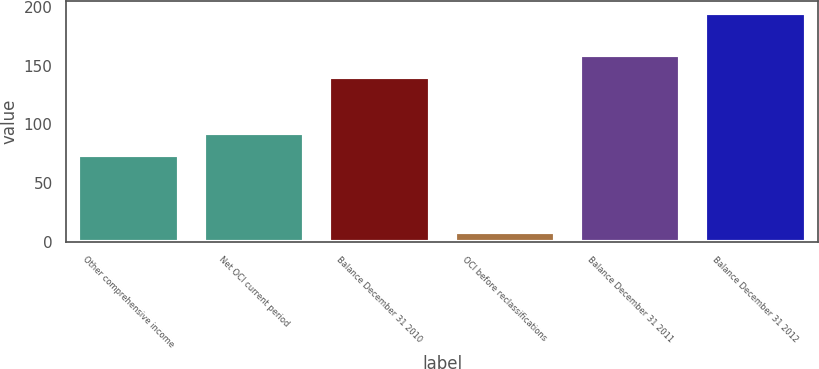<chart> <loc_0><loc_0><loc_500><loc_500><bar_chart><fcel>Other comprehensive income<fcel>Net OCI current period<fcel>Balance December 31 2010<fcel>OCI before reclassifications<fcel>Balance December 31 2011<fcel>Balance December 31 2012<nl><fcel>74<fcel>92.7<fcel>140<fcel>8<fcel>158.7<fcel>195<nl></chart> 